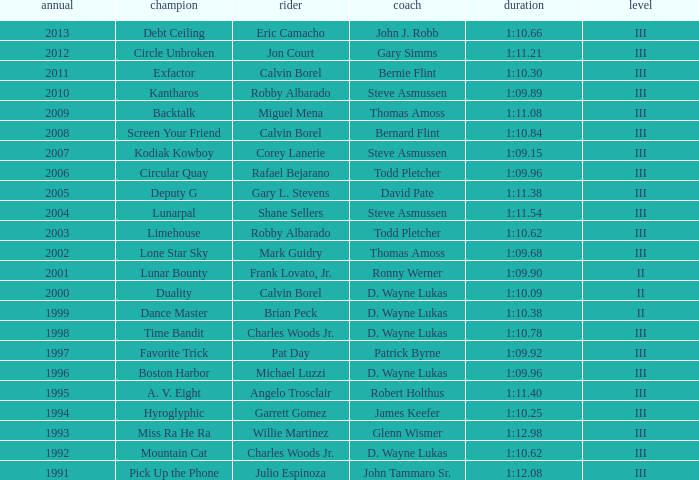What was the time for Screen Your Friend? 1:10.84. 